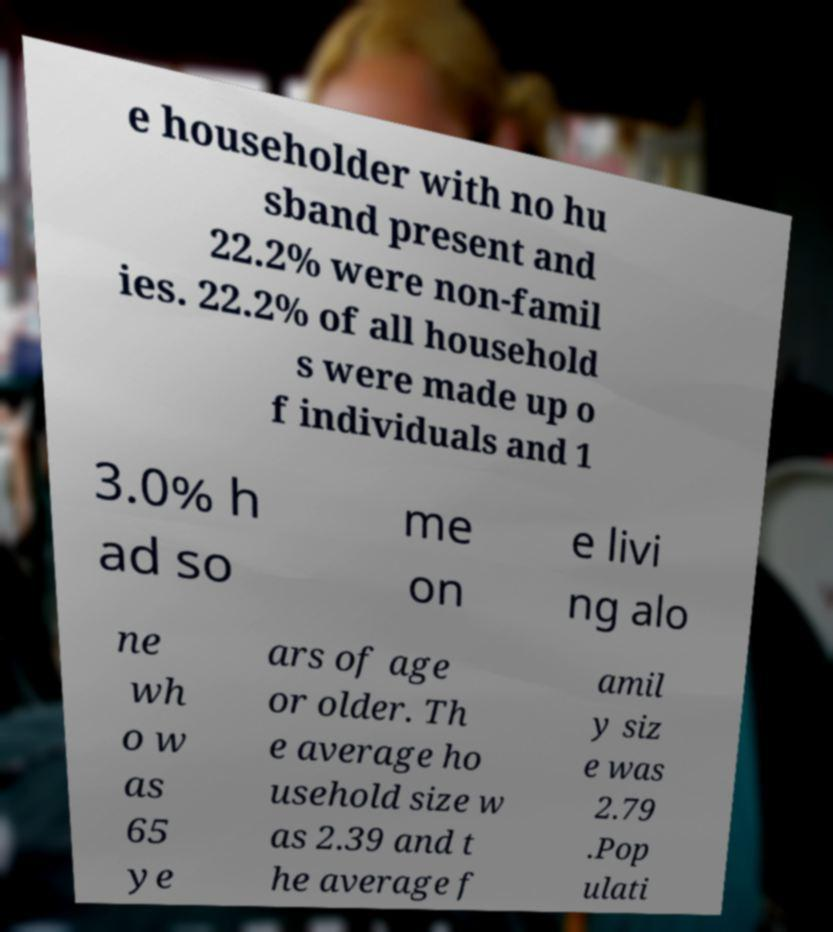Could you assist in decoding the text presented in this image and type it out clearly? e householder with no hu sband present and 22.2% were non-famil ies. 22.2% of all household s were made up o f individuals and 1 3.0% h ad so me on e livi ng alo ne wh o w as 65 ye ars of age or older. Th e average ho usehold size w as 2.39 and t he average f amil y siz e was 2.79 .Pop ulati 